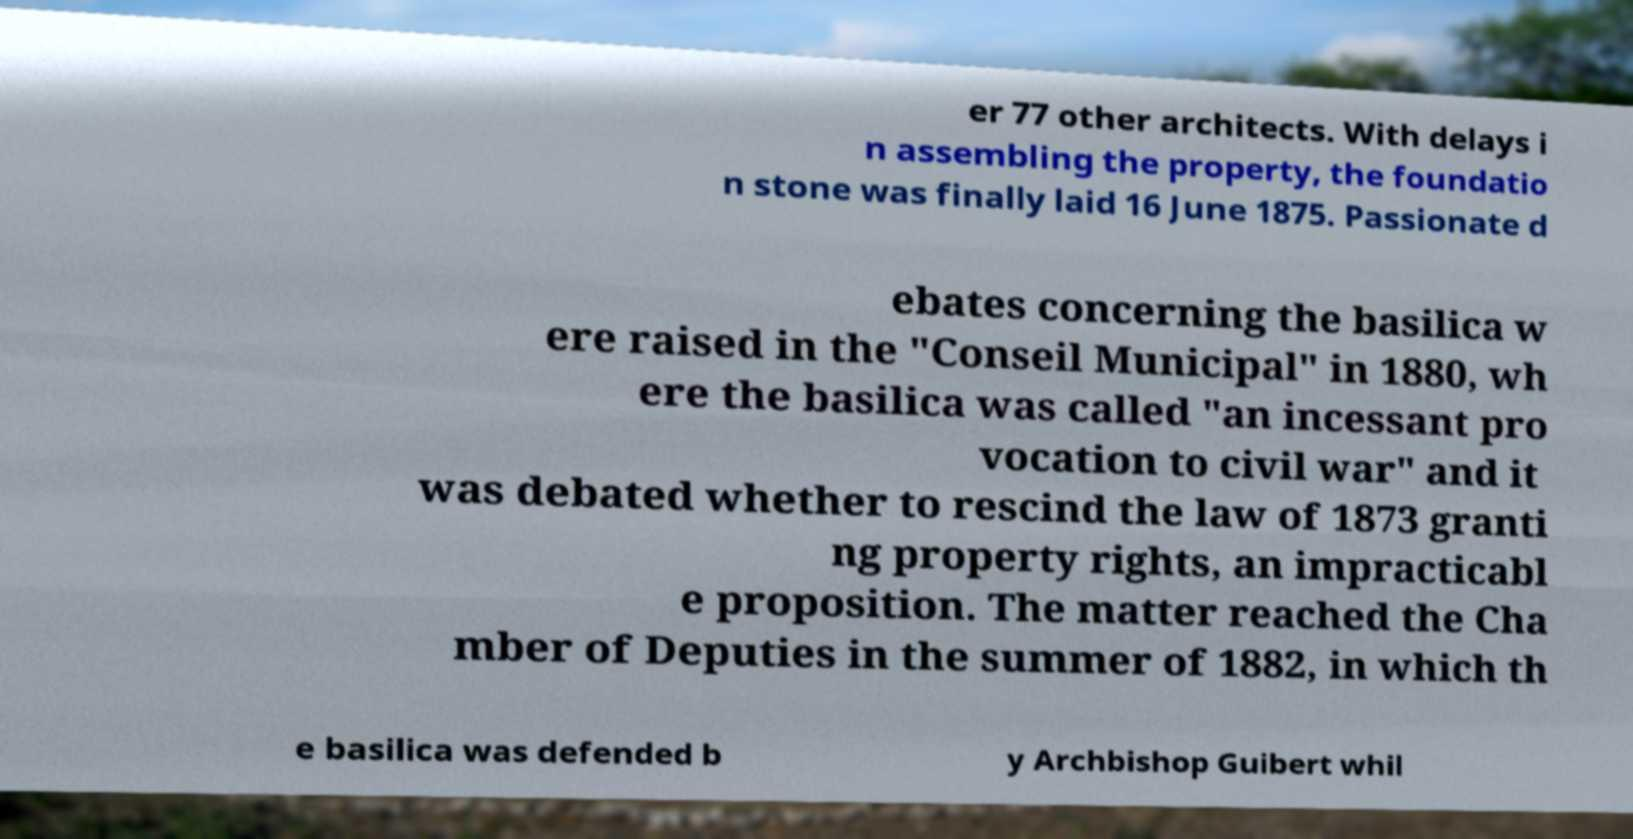Please read and relay the text visible in this image. What does it say? er 77 other architects. With delays i n assembling the property, the foundatio n stone was finally laid 16 June 1875. Passionate d ebates concerning the basilica w ere raised in the "Conseil Municipal" in 1880, wh ere the basilica was called "an incessant pro vocation to civil war" and it was debated whether to rescind the law of 1873 granti ng property rights, an impracticabl e proposition. The matter reached the Cha mber of Deputies in the summer of 1882, in which th e basilica was defended b y Archbishop Guibert whil 